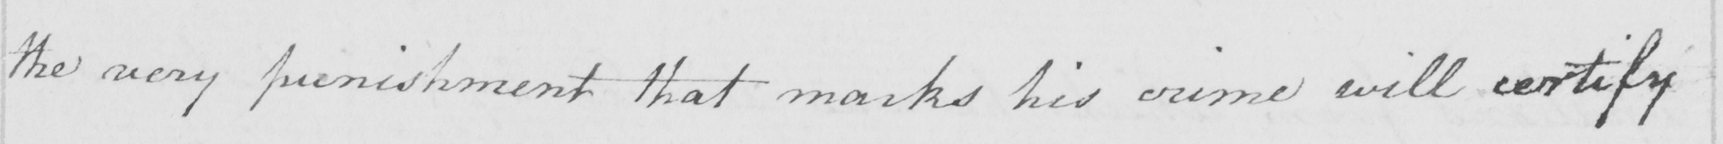What is written in this line of handwriting? the very punishment that marks his crime will certify 